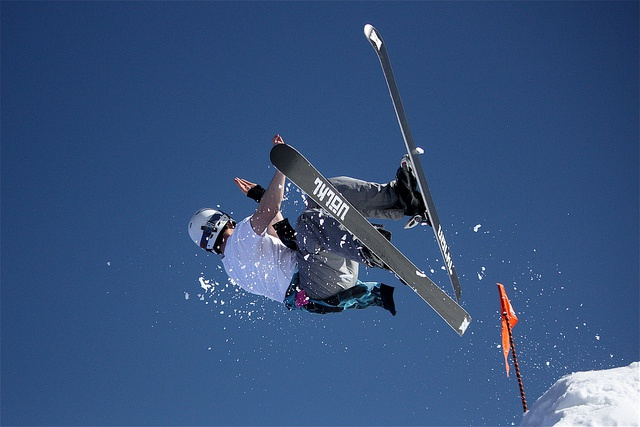Describe the objects in this image and their specific colors. I can see people in navy, black, gray, and darkgray tones and skis in navy, gray, black, and lightgray tones in this image. 